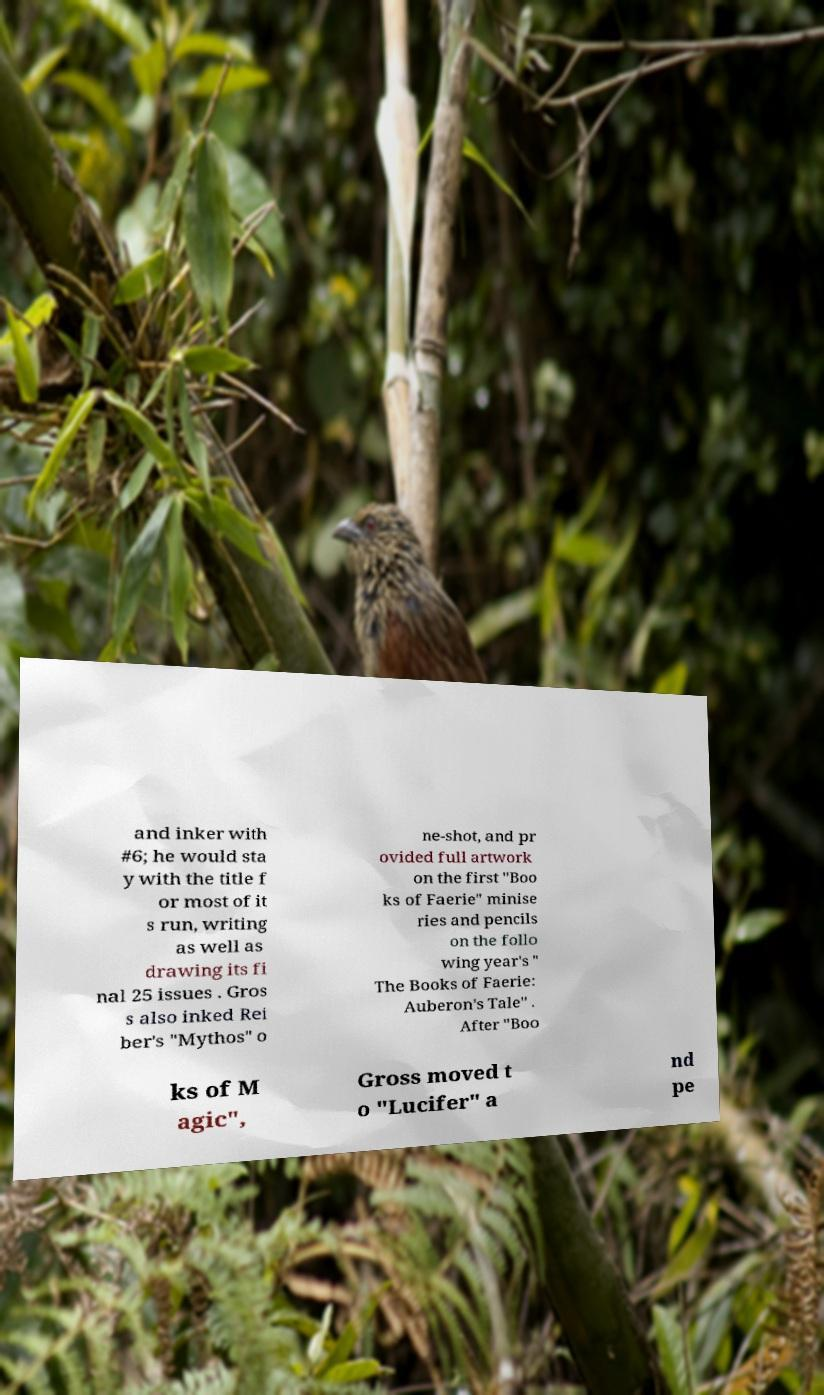Can you read and provide the text displayed in the image?This photo seems to have some interesting text. Can you extract and type it out for me? and inker with #6; he would sta y with the title f or most of it s run, writing as well as drawing its fi nal 25 issues . Gros s also inked Rei ber's "Mythos" o ne-shot, and pr ovided full artwork on the first "Boo ks of Faerie" minise ries and pencils on the follo wing year's " The Books of Faerie: Auberon's Tale" . After "Boo ks of M agic", Gross moved t o "Lucifer" a nd pe 